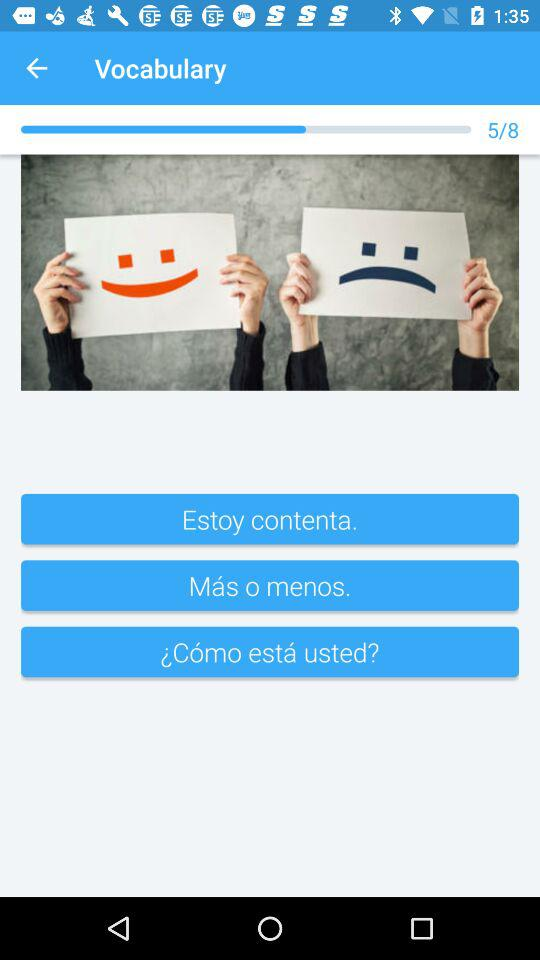Which image number is the user on? The user is on image number 5. 